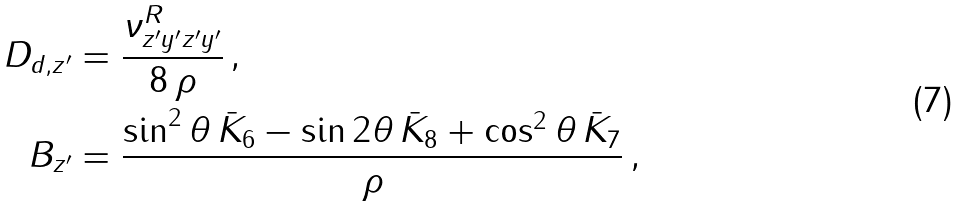Convert formula to latex. <formula><loc_0><loc_0><loc_500><loc_500>D _ { d , z ^ { \prime } } & = \frac { \nu _ { z ^ { \prime } y ^ { \prime } z ^ { \prime } y ^ { \prime } } ^ { R } } { 8 \, \rho } \, , \\ B _ { z ^ { \prime } } & = \frac { \sin ^ { 2 } \theta \, \bar { K } _ { 6 } - \sin 2 \theta \, \bar { K } _ { 8 } + \cos ^ { 2 } \theta \, \bar { K } _ { 7 } } { \rho } \, ,</formula> 